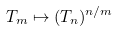<formula> <loc_0><loc_0><loc_500><loc_500>T _ { m } \mapsto ( T _ { n } ) ^ { n / m }</formula> 